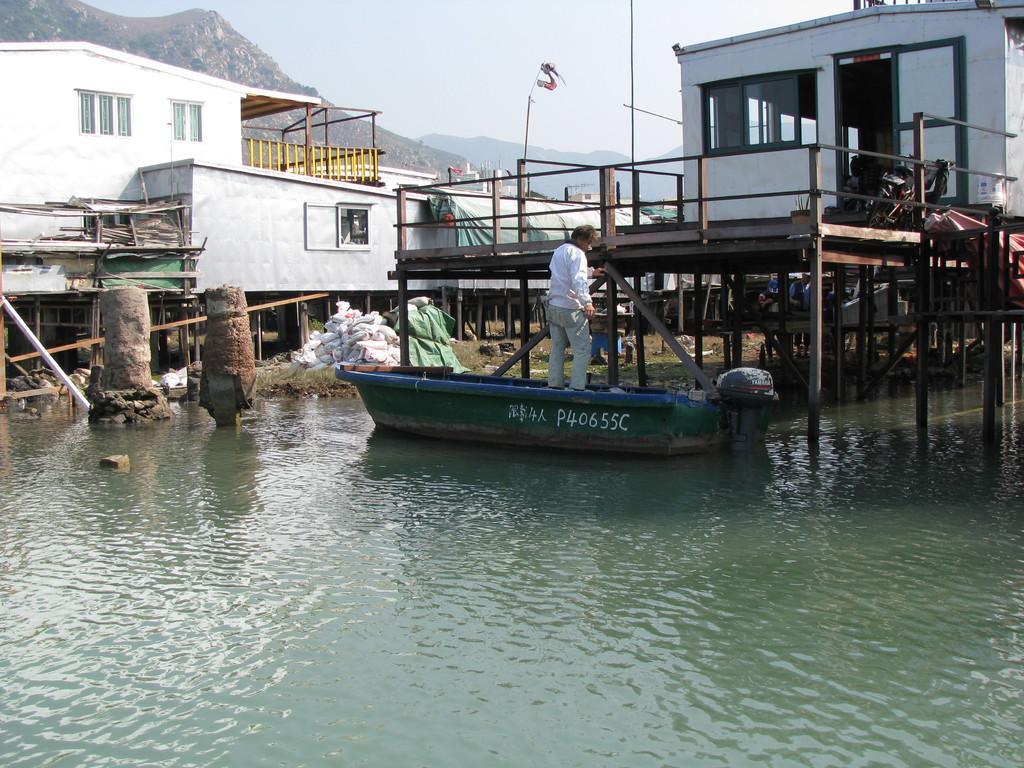How would you summarize this image in a sentence or two? In this image I can see few houses on the bridge. I can see a person standing on the boat. I can see windows, mountains, poles, bags and the water. The sky is in blue color. 